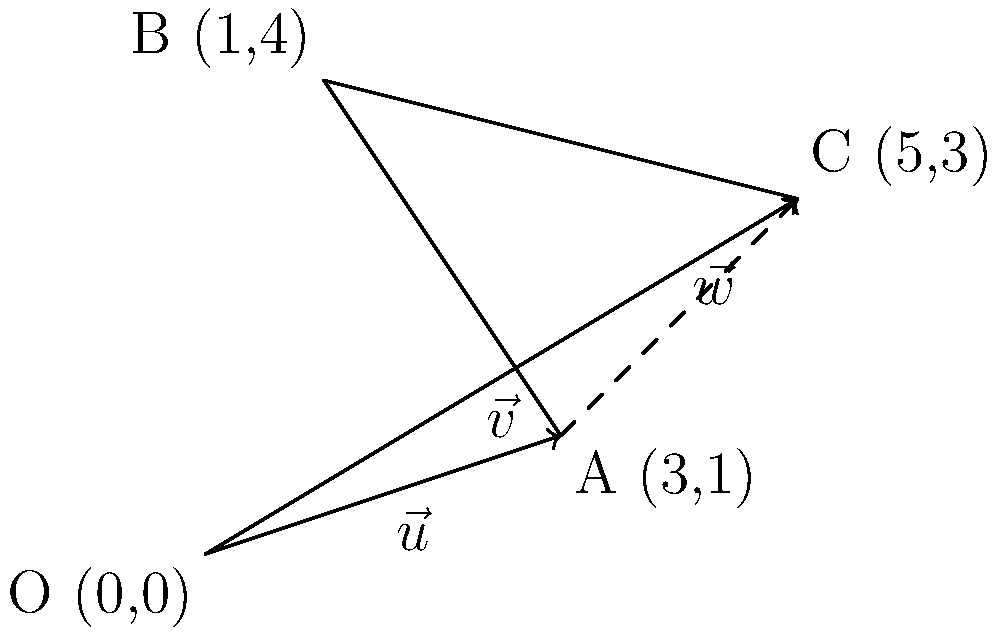In planning an eco-friendly home, you need to optimize tree placement for shading and wind protection. Given the vectors $\vec{u} = 3\hat{i} + \hat{j}$ and $\vec{v} = 5\hat{i} + 3\hat{j}$ representing two potential tree locations relative to the house at the origin, determine the vector $\vec{w}$ that represents the position of the second tree relative to the first tree. To find the vector $\vec{w}$ that represents the position of the second tree relative to the first tree, we need to use vector subtraction. Here's the step-by-step process:

1) We have:
   $\vec{u} = 3\hat{i} + \hat{j}$ (first tree's position)
   $\vec{v} = 5\hat{i} + 3\hat{j}$ (second tree's position)

2) The vector $\vec{w}$ can be found by subtracting $\vec{u}$ from $\vec{v}$:
   $\vec{w} = \vec{v} - \vec{u}$

3) Substituting the given vectors:
   $\vec{w} = (5\hat{i} + 3\hat{j}) - (3\hat{i} + \hat{j})$

4) Subtracting the components:
   $\vec{w} = (5\hat{i} - 3\hat{i}) + (3\hat{j} - \hat{j})$

5) Simplifying:
   $\vec{w} = 2\hat{i} + 2\hat{j}$

Therefore, the vector $\vec{w}$ representing the position of the second tree relative to the first tree is $2\hat{i} + 2\hat{j}$.
Answer: $\vec{w} = 2\hat{i} + 2\hat{j}$ 